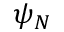<formula> <loc_0><loc_0><loc_500><loc_500>\psi _ { N }</formula> 